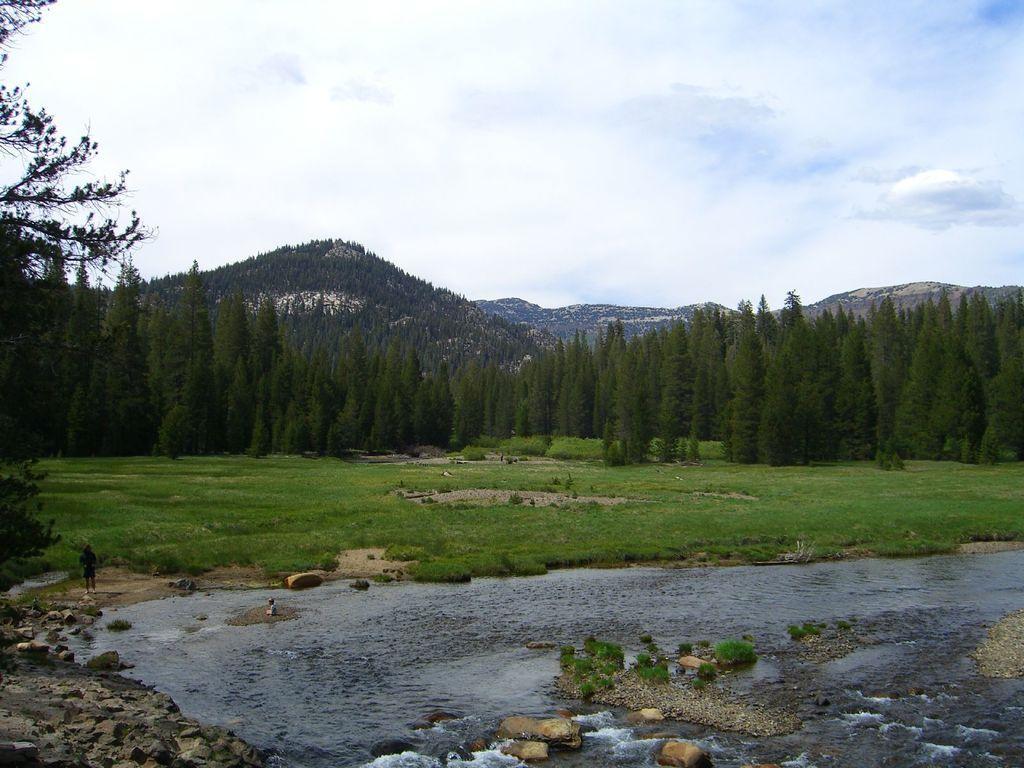Describe this image in one or two sentences. In this image I can see at the bottom water is flowing, in the middle there are trees. At the back side there are hills, at the top it is the sky. 